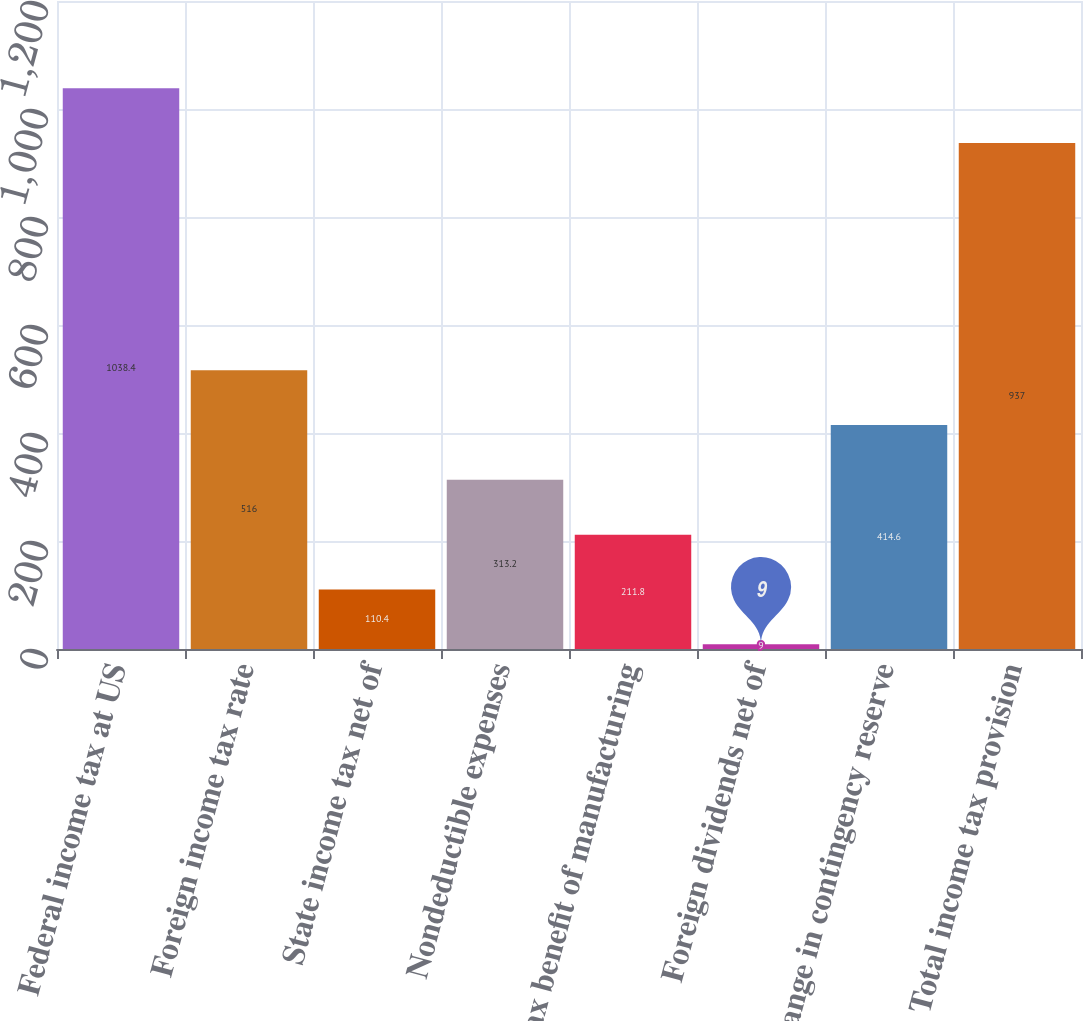Convert chart. <chart><loc_0><loc_0><loc_500><loc_500><bar_chart><fcel>Federal income tax at US<fcel>Foreign income tax rate<fcel>State income tax net of<fcel>Nondeductible expenses<fcel>Tax benefit of manufacturing<fcel>Foreign dividends net of<fcel>Change in contingency reserve<fcel>Total income tax provision<nl><fcel>1038.4<fcel>516<fcel>110.4<fcel>313.2<fcel>211.8<fcel>9<fcel>414.6<fcel>937<nl></chart> 